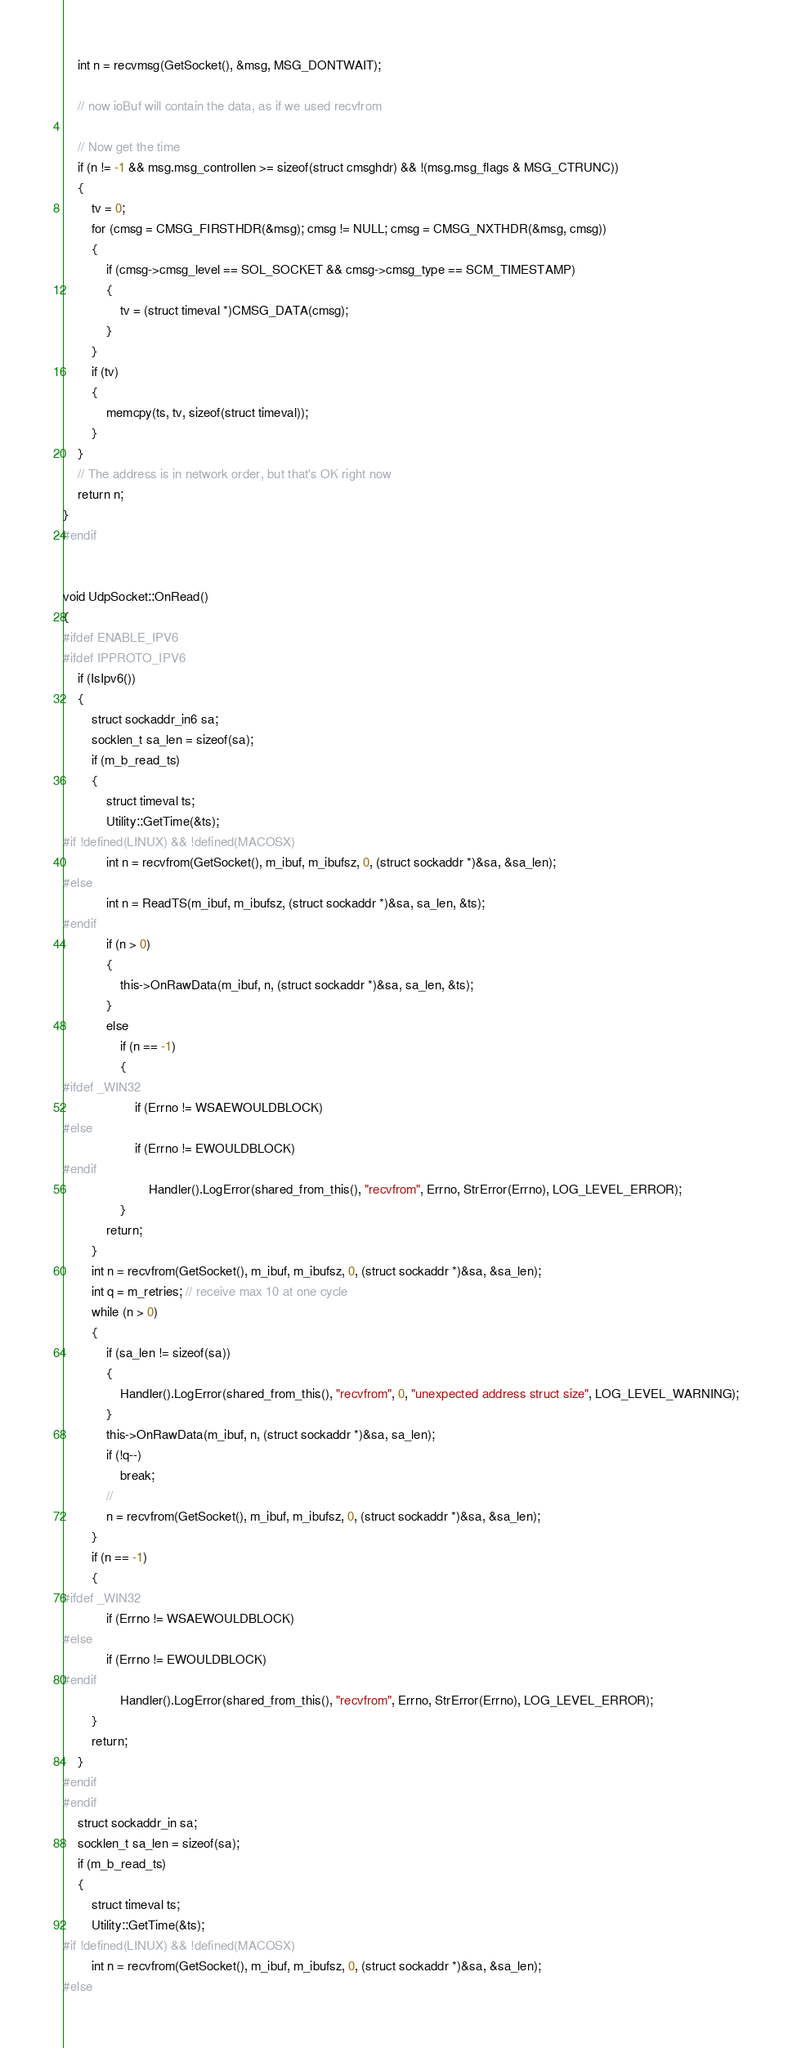Convert code to text. <code><loc_0><loc_0><loc_500><loc_500><_C++_>    int n = recvmsg(GetSocket(), &msg, MSG_DONTWAIT);

    // now ioBuf will contain the data, as if we used recvfrom

    // Now get the time
    if (n != -1 && msg.msg_controllen >= sizeof(struct cmsghdr) && !(msg.msg_flags & MSG_CTRUNC))
    {
        tv = 0;
        for (cmsg = CMSG_FIRSTHDR(&msg); cmsg != NULL; cmsg = CMSG_NXTHDR(&msg, cmsg))
        {
            if (cmsg->cmsg_level == SOL_SOCKET && cmsg->cmsg_type == SCM_TIMESTAMP)
            {
                tv = (struct timeval *)CMSG_DATA(cmsg);
            }
        }
        if (tv)
        {
            memcpy(ts, tv, sizeof(struct timeval));
        }
    }
    // The address is in network order, but that's OK right now
    return n;
}
#endif


void UdpSocket::OnRead()
{
#ifdef ENABLE_IPV6
#ifdef IPPROTO_IPV6
    if (IsIpv6())
    {
        struct sockaddr_in6 sa;
        socklen_t sa_len = sizeof(sa);
        if (m_b_read_ts)
        {
            struct timeval ts;
            Utility::GetTime(&ts);
#if !defined(LINUX) && !defined(MACOSX)
            int n = recvfrom(GetSocket(), m_ibuf, m_ibufsz, 0, (struct sockaddr *)&sa, &sa_len);
#else
            int n = ReadTS(m_ibuf, m_ibufsz, (struct sockaddr *)&sa, sa_len, &ts);
#endif
            if (n > 0)
            {
                this->OnRawData(m_ibuf, n, (struct sockaddr *)&sa, sa_len, &ts);
            }
            else
                if (n == -1)
                {
#ifdef _WIN32
                    if (Errno != WSAEWOULDBLOCK)
#else
                    if (Errno != EWOULDBLOCK)
#endif
                        Handler().LogError(shared_from_this(), "recvfrom", Errno, StrError(Errno), LOG_LEVEL_ERROR);
                }
            return;
        }
        int n = recvfrom(GetSocket(), m_ibuf, m_ibufsz, 0, (struct sockaddr *)&sa, &sa_len);
        int q = m_retries; // receive max 10 at one cycle
        while (n > 0)
        {
            if (sa_len != sizeof(sa))
            {
                Handler().LogError(shared_from_this(), "recvfrom", 0, "unexpected address struct size", LOG_LEVEL_WARNING);
            }
            this->OnRawData(m_ibuf, n, (struct sockaddr *)&sa, sa_len);
            if (!q--)
                break;
            //
            n = recvfrom(GetSocket(), m_ibuf, m_ibufsz, 0, (struct sockaddr *)&sa, &sa_len);
        }
        if (n == -1)
        {
#ifdef _WIN32
            if (Errno != WSAEWOULDBLOCK)
#else
            if (Errno != EWOULDBLOCK)
#endif
                Handler().LogError(shared_from_this(), "recvfrom", Errno, StrError(Errno), LOG_LEVEL_ERROR);
        }
        return;
    }
#endif
#endif
    struct sockaddr_in sa;
    socklen_t sa_len = sizeof(sa);
    if (m_b_read_ts)
    {
        struct timeval ts;
        Utility::GetTime(&ts);
#if !defined(LINUX) && !defined(MACOSX)
        int n = recvfrom(GetSocket(), m_ibuf, m_ibufsz, 0, (struct sockaddr *)&sa, &sa_len);
#else</code> 